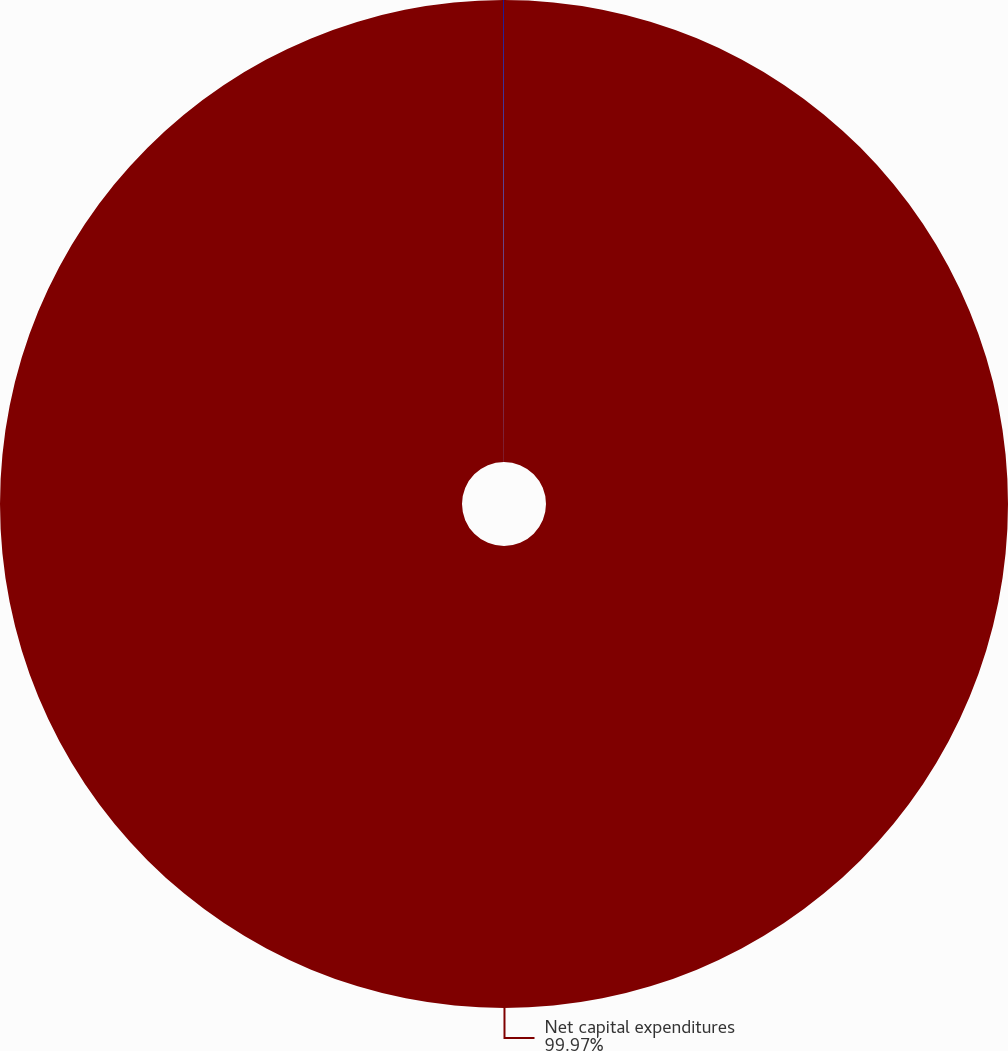<chart> <loc_0><loc_0><loc_500><loc_500><pie_chart><fcel>Net capital expenditures<fcel>of net earnings<nl><fcel>99.97%<fcel>0.03%<nl></chart> 